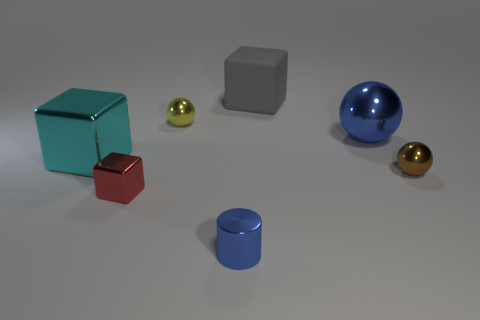There is a small cylinder that is in front of the small shiny sphere that is to the right of the rubber thing; are there any big gray objects that are on the left side of it?
Give a very brief answer. No. The cyan thing that is the same size as the gray block is what shape?
Offer a terse response. Cube. There is a metal ball that is to the left of the small metal cylinder; is its size the same as the metallic block that is in front of the brown thing?
Your answer should be very brief. Yes. What number of big blue shiny balls are there?
Give a very brief answer. 1. There is a metallic thing that is on the right side of the large metallic object to the right of the big block left of the tiny yellow shiny sphere; what is its size?
Ensure brevity in your answer.  Small. Does the metallic cylinder have the same color as the big ball?
Offer a very short reply. Yes. There is a big blue shiny object; how many metal balls are left of it?
Provide a short and direct response. 1. Are there the same number of brown things behind the large cyan object and large metallic spheres?
Your answer should be compact. No. How many things are either yellow balls or brown objects?
Provide a short and direct response. 2. Are there any other things that are the same shape as the gray matte object?
Give a very brief answer. Yes. 